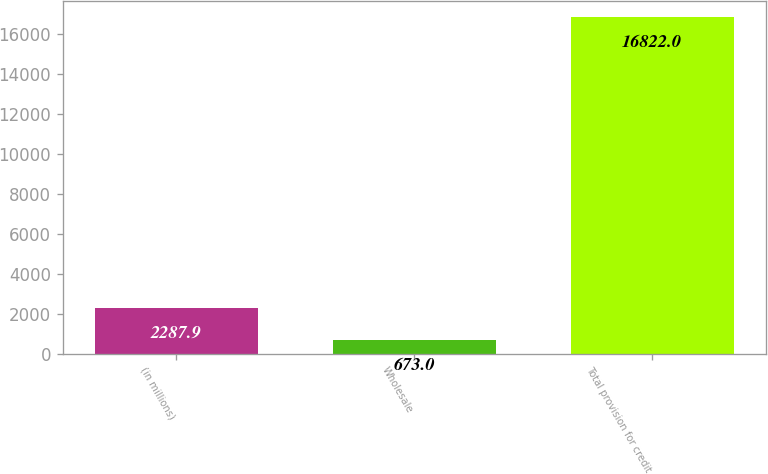Convert chart. <chart><loc_0><loc_0><loc_500><loc_500><bar_chart><fcel>(in millions)<fcel>Wholesale<fcel>Total provision for credit<nl><fcel>2287.9<fcel>673<fcel>16822<nl></chart> 